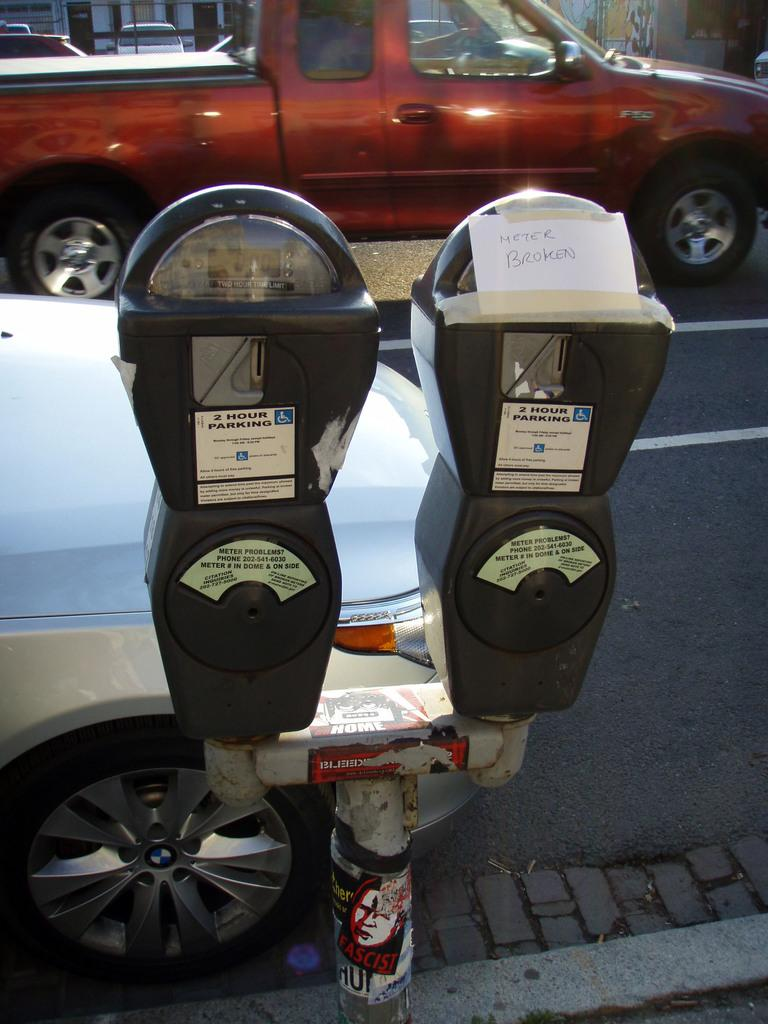<image>
Share a concise interpretation of the image provided. 2 hour parking meters share the same post on the street. 